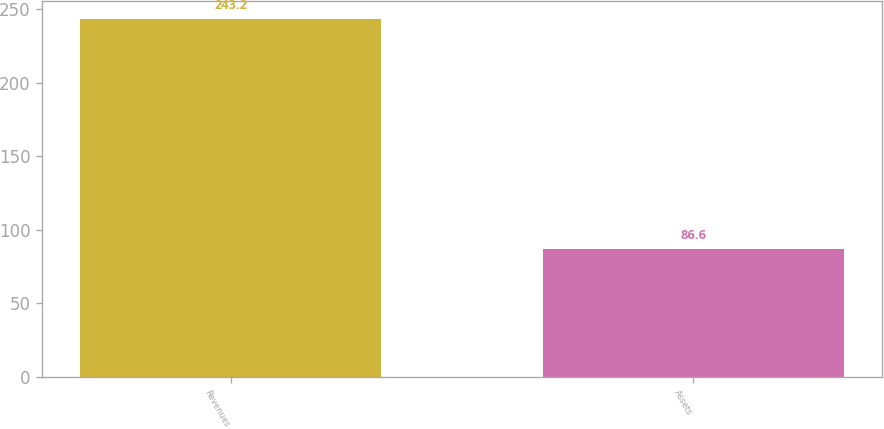Convert chart to OTSL. <chart><loc_0><loc_0><loc_500><loc_500><bar_chart><fcel>Revenues<fcel>Assets<nl><fcel>243.2<fcel>86.6<nl></chart> 